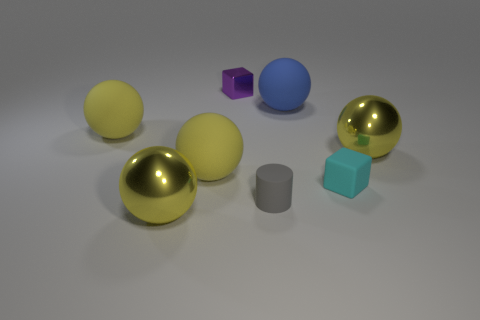How many yellow spheres must be subtracted to get 1 yellow spheres? 3 Subtract all big blue spheres. How many spheres are left? 4 Subtract all yellow blocks. How many yellow spheres are left? 4 Subtract all blue balls. How many balls are left? 4 Add 1 large blue balls. How many objects exist? 9 Subtract all green spheres. Subtract all purple cubes. How many spheres are left? 5 Subtract all blocks. How many objects are left? 6 Subtract all tiny yellow metallic spheres. Subtract all small cyan matte blocks. How many objects are left? 7 Add 3 rubber cylinders. How many rubber cylinders are left? 4 Add 4 gray cylinders. How many gray cylinders exist? 5 